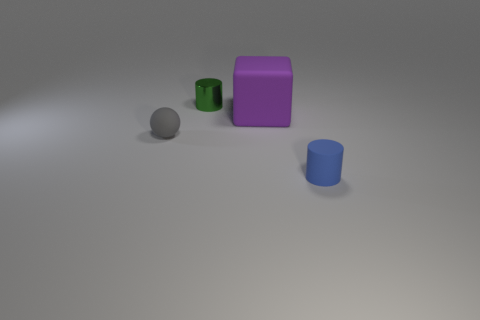Are there any other things that are the same size as the purple matte thing?
Give a very brief answer. No. What number of spheres are the same size as the blue matte cylinder?
Ensure brevity in your answer.  1. There is a matte object that is both to the right of the tiny green thing and in front of the large rubber block; what is its color?
Your response must be concise. Blue. Is the number of things behind the large object greater than the number of small yellow cylinders?
Keep it short and to the point. Yes. Are there any tiny gray blocks?
Provide a succinct answer. No. What number of small things are either cyan shiny spheres or blue things?
Provide a succinct answer. 1. The tiny gray thing that is made of the same material as the purple object is what shape?
Your response must be concise. Sphere. What size is the rubber object behind the ball?
Provide a short and direct response. Large. There is a tiny gray thing; what shape is it?
Make the answer very short. Sphere. There is a rubber thing that is to the left of the large rubber block; is it the same size as the matte thing that is behind the small gray object?
Ensure brevity in your answer.  No. 